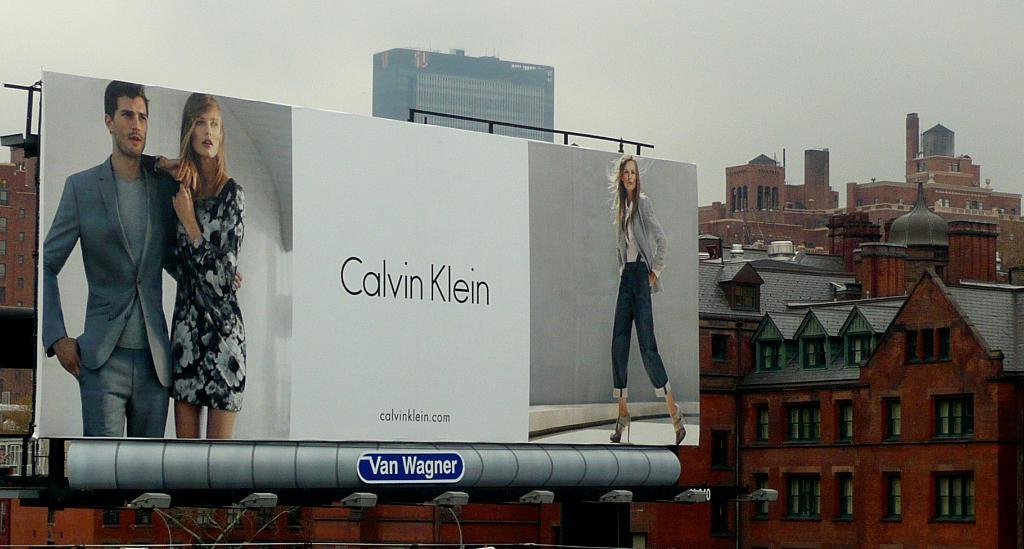<image>
Describe the image concisely. a large sign with Calvin Klein written on it 